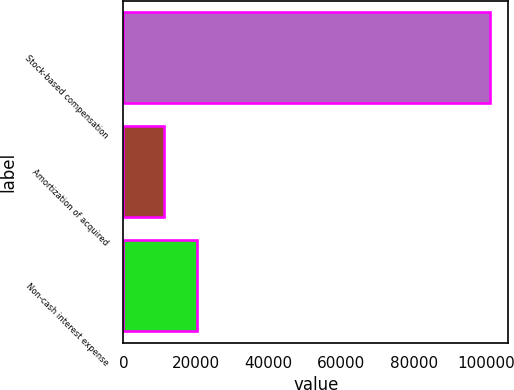<chart> <loc_0><loc_0><loc_500><loc_500><bar_chart><fcel>Stock-based compensation<fcel>Amortization of acquired<fcel>Non-cash interest expense<nl><fcel>100959<fcel>11077<fcel>20355<nl></chart> 